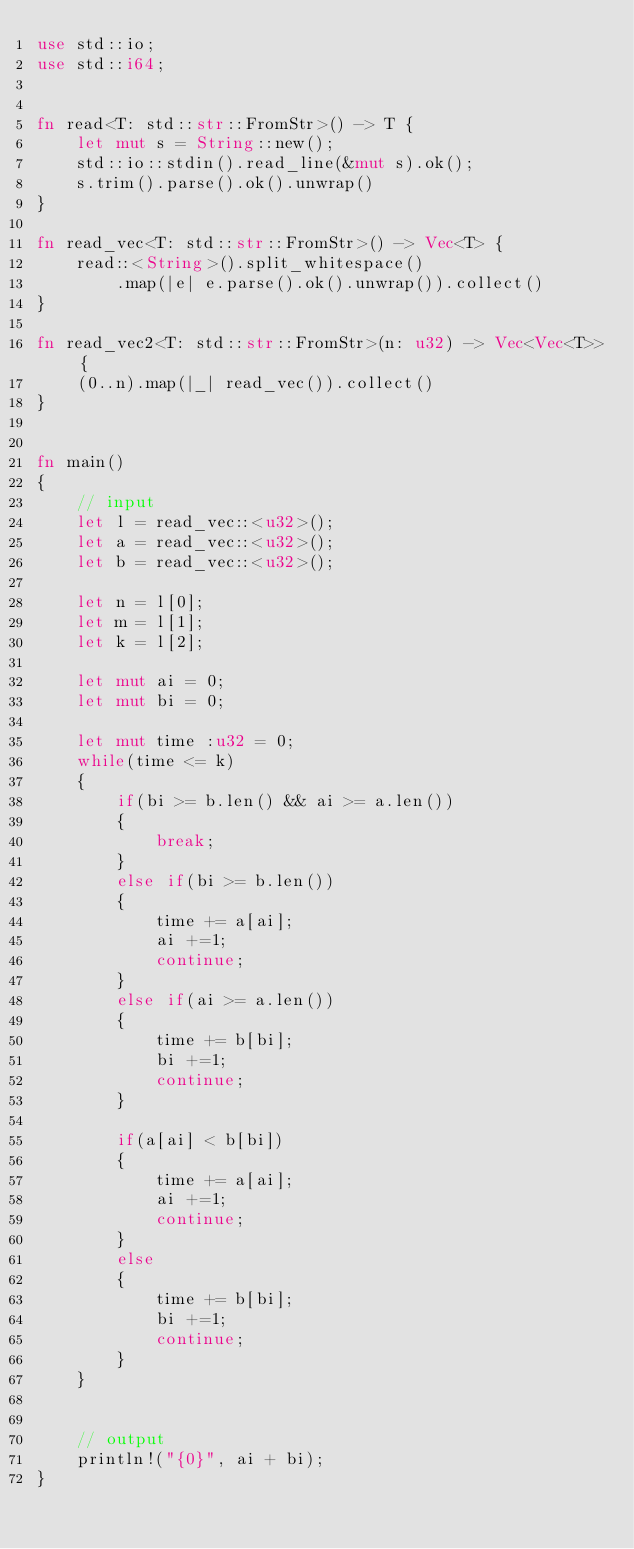<code> <loc_0><loc_0><loc_500><loc_500><_Rust_>use std::io;
use std::i64;


fn read<T: std::str::FromStr>() -> T {
    let mut s = String::new();
    std::io::stdin().read_line(&mut s).ok();
    s.trim().parse().ok().unwrap()
}

fn read_vec<T: std::str::FromStr>() -> Vec<T> {
    read::<String>().split_whitespace()
        .map(|e| e.parse().ok().unwrap()).collect()
}

fn read_vec2<T: std::str::FromStr>(n: u32) -> Vec<Vec<T>> {
    (0..n).map(|_| read_vec()).collect()
}


fn main()
{
    // input
    let l = read_vec::<u32>();
    let a = read_vec::<u32>();
    let b = read_vec::<u32>();

    let n = l[0];
    let m = l[1];
    let k = l[2];

    let mut ai = 0;
    let mut bi = 0;

    let mut time :u32 = 0;
    while(time <= k)
    {
        if(bi >= b.len() && ai >= a.len())
        {
            break;
        }
        else if(bi >= b.len())
        {
            time += a[ai];
            ai +=1;
            continue;
        }
        else if(ai >= a.len())
        {
            time += b[bi];
            bi +=1;
            continue;
        }

        if(a[ai] < b[bi])
        {
            time += a[ai];
            ai +=1;
            continue;
        }
        else
        {
            time += b[bi];
            bi +=1;
            continue;
        }
    }


    // output
    println!("{0}", ai + bi);
}</code> 